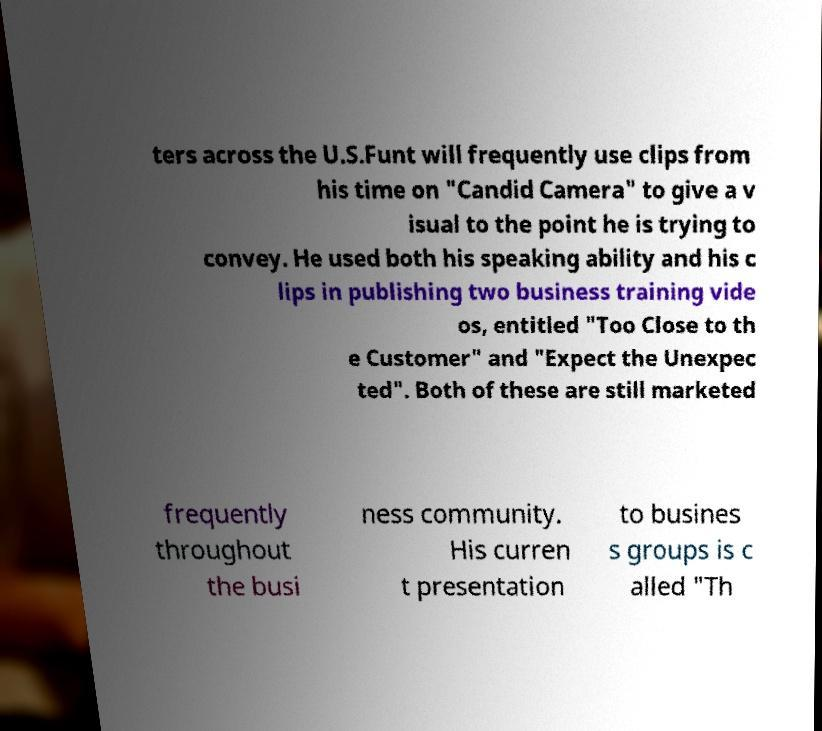For documentation purposes, I need the text within this image transcribed. Could you provide that? ters across the U.S.Funt will frequently use clips from his time on "Candid Camera" to give a v isual to the point he is trying to convey. He used both his speaking ability and his c lips in publishing two business training vide os, entitled "Too Close to th e Customer" and "Expect the Unexpec ted". Both of these are still marketed frequently throughout the busi ness community. His curren t presentation to busines s groups is c alled "Th 